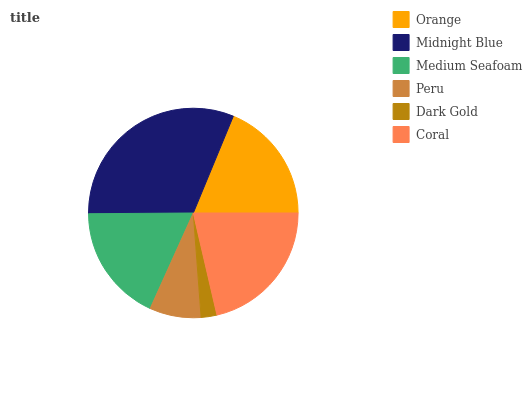Is Dark Gold the minimum?
Answer yes or no. Yes. Is Midnight Blue the maximum?
Answer yes or no. Yes. Is Medium Seafoam the minimum?
Answer yes or no. No. Is Medium Seafoam the maximum?
Answer yes or no. No. Is Midnight Blue greater than Medium Seafoam?
Answer yes or no. Yes. Is Medium Seafoam less than Midnight Blue?
Answer yes or no. Yes. Is Medium Seafoam greater than Midnight Blue?
Answer yes or no. No. Is Midnight Blue less than Medium Seafoam?
Answer yes or no. No. Is Orange the high median?
Answer yes or no. Yes. Is Medium Seafoam the low median?
Answer yes or no. Yes. Is Peru the high median?
Answer yes or no. No. Is Midnight Blue the low median?
Answer yes or no. No. 